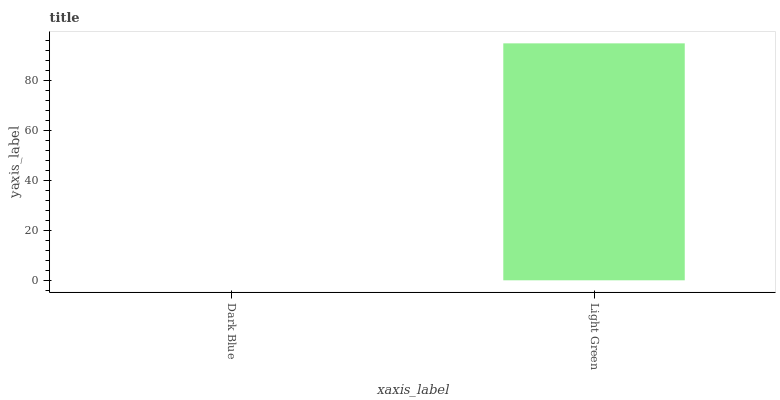Is Light Green the minimum?
Answer yes or no. No. Is Light Green greater than Dark Blue?
Answer yes or no. Yes. Is Dark Blue less than Light Green?
Answer yes or no. Yes. Is Dark Blue greater than Light Green?
Answer yes or no. No. Is Light Green less than Dark Blue?
Answer yes or no. No. Is Light Green the high median?
Answer yes or no. Yes. Is Dark Blue the low median?
Answer yes or no. Yes. Is Dark Blue the high median?
Answer yes or no. No. Is Light Green the low median?
Answer yes or no. No. 